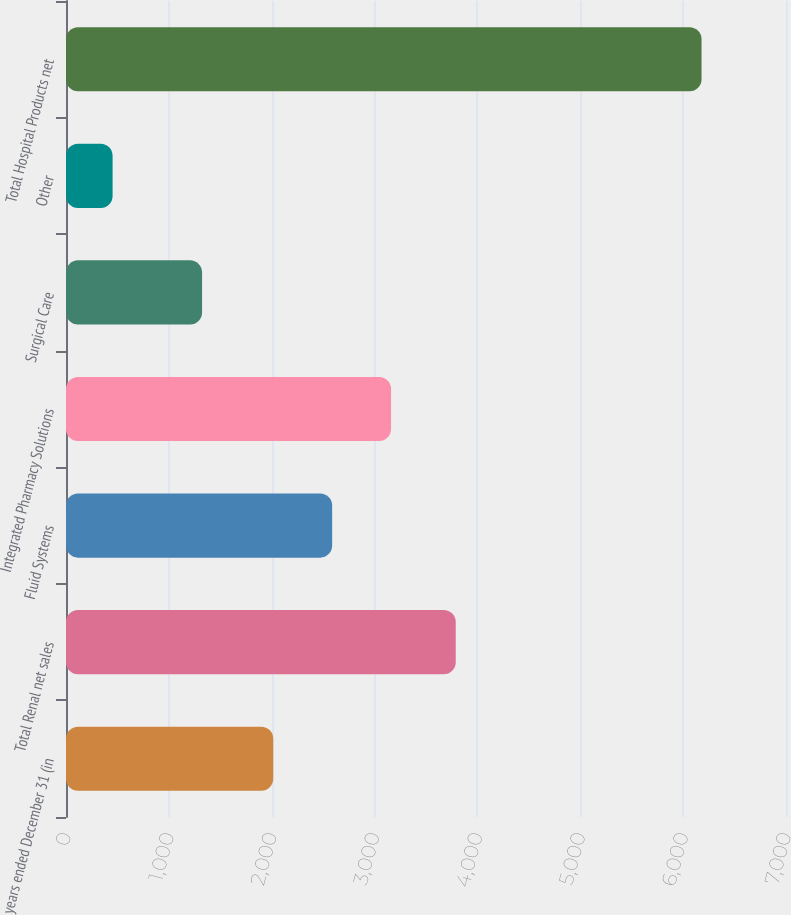<chart> <loc_0><loc_0><loc_500><loc_500><bar_chart><fcel>years ended December 31 (in<fcel>Total Renal net sales<fcel>Fluid Systems<fcel>Integrated Pharmacy Solutions<fcel>Surgical Care<fcel>Other<fcel>Total Hospital Products net<nl><fcel>2015<fcel>3789<fcel>2587.6<fcel>3160.2<fcel>1323<fcel>453<fcel>6179<nl></chart> 